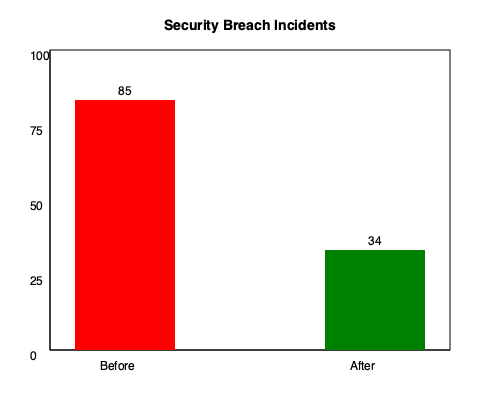Based on the bar graph comparing security breach incidents before and after implementing new cybersecurity measures, calculate the percentage reduction in incidents. Round your answer to the nearest whole number. To calculate the percentage reduction in security breach incidents, we'll follow these steps:

1. Identify the number of incidents before and after:
   - Before: 85 incidents
   - After: 34 incidents

2. Calculate the difference in incidents:
   $85 - 34 = 51$

3. Calculate the percentage reduction:
   Percentage reduction = $\frac{\text{Difference}}{\text{Original number}} \times 100\%$
   
   $\frac{51}{85} \times 100\% = 0.6 \times 100\% = 60\%$

4. Round to the nearest whole number:
   60% (no rounding needed in this case)

Therefore, the percentage reduction in security breach incidents after implementing new cybersecurity measures is 60%.
Answer: 60% 